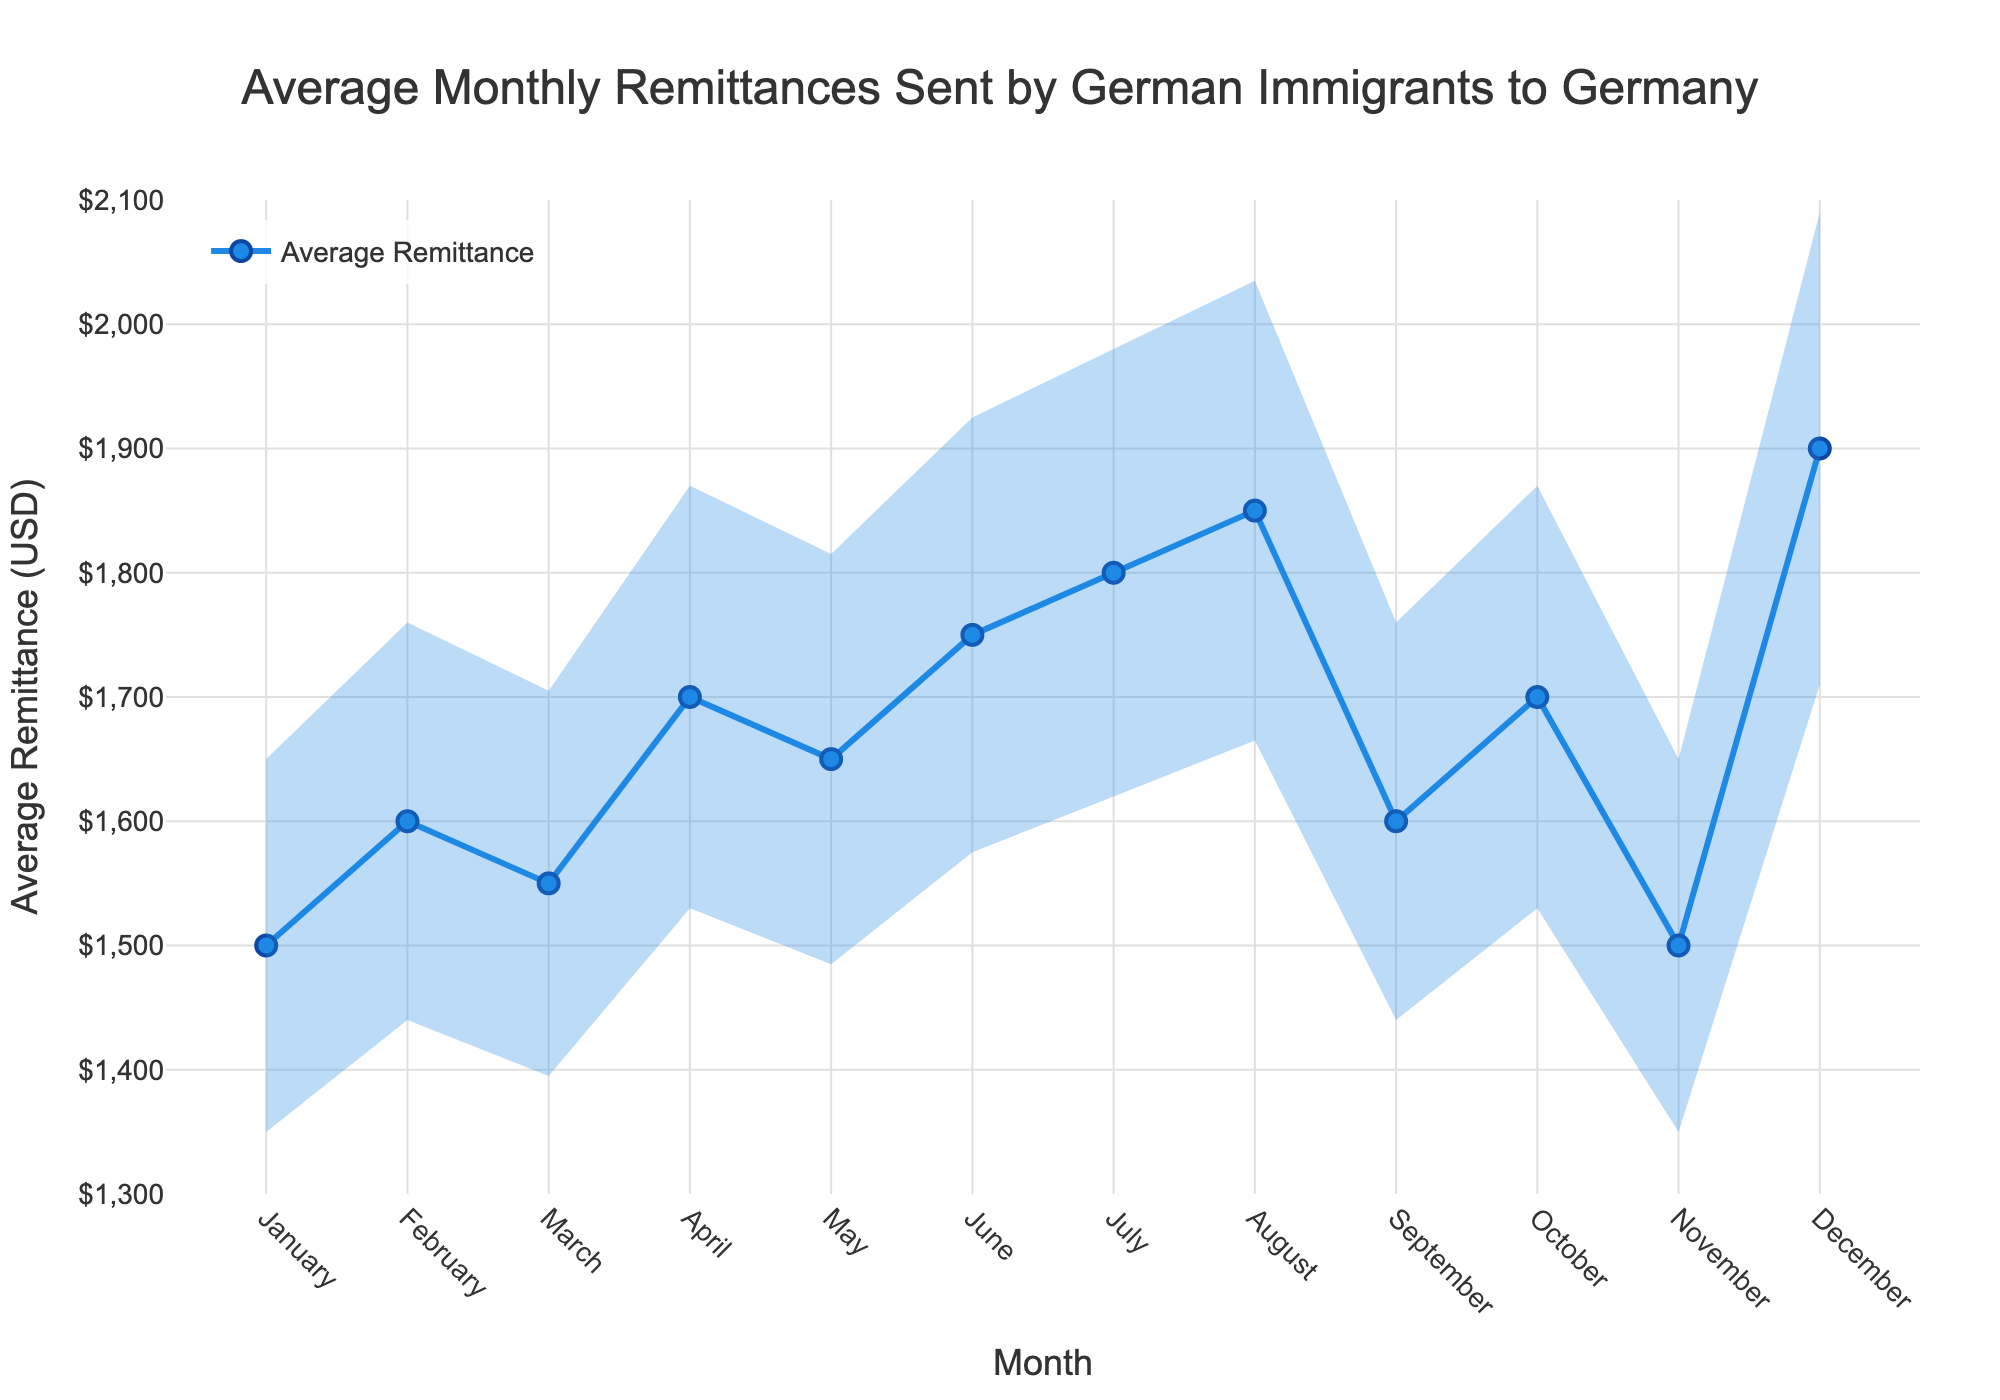What is the title of the figure? The title is located at the top of the figure, indicating the overall content.
Answer: Average Monthly Remittances Sent by German Immigrants to Germany What is the average remittance amount in July? Locate the point on the plot corresponding to July and see its y-value.
Answer: $1800 Which month has the highest average remittance? Identify the highest point on the plot and note the corresponding month on the x-axis.
Answer: December What is the error bar value for February? Find the error bar associated with February by looking at the length of the error bar on the plot.
Answer: $160 In which month does the minimum average remittance occur? Locate the lowest point on the plot and identify its corresponding month on the x-axis.
Answer: January and November What is the range of average remittances sent in August (including error bars)? To get the range, add and subtract the error bar value from the average remittance value for August.
Answer: $1665 - $2035 How does the average remittance in May compare to September? Compare the y-values for May and September on the plot to see which is higher.
Answer: Higher in May Which months' remittances have error bars overlapping? Look for error bars that extend horizontally at least to the height of another bar, indicating overlap.
Answer: February and April By how much did the average remittance increase from January to June? Subtract the average remittance in January from that in June.
Answer: $250 During which month do the error bars represent the highest uncertainty? Identify the month with the longest error bar by visually comparing the lengths of all error bars.
Answer: December 